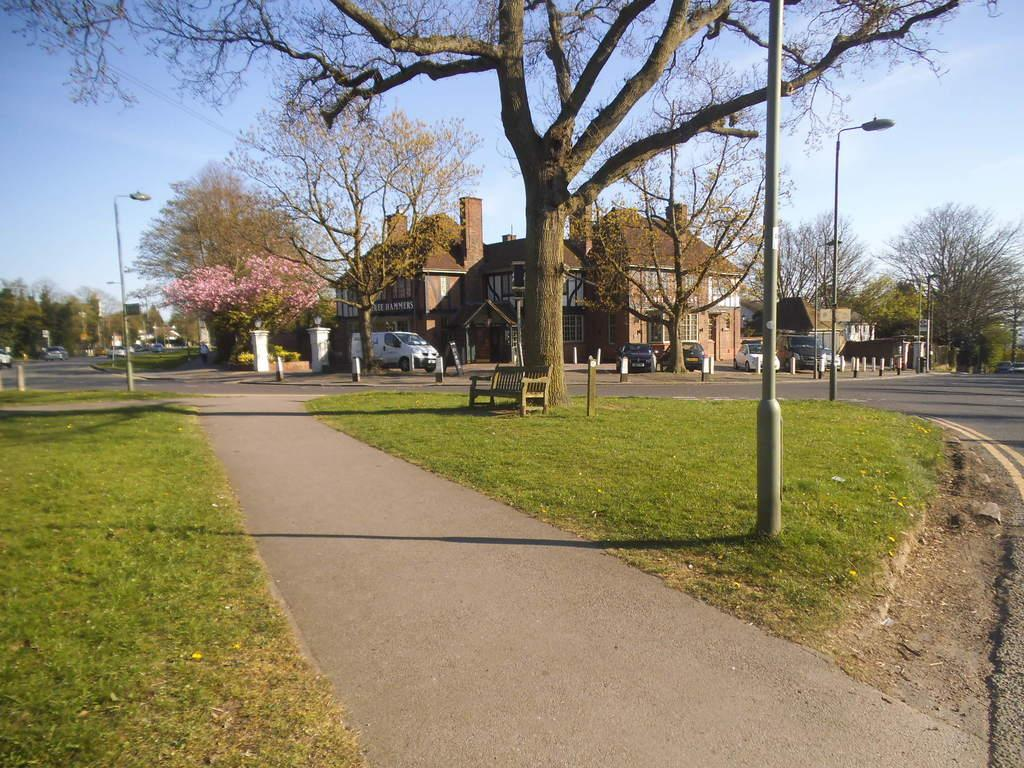What type of vegetation is present in the image? There is grass in the image. What structures are present to provide illumination in the image? There are lights on poles in the image. What type of seating is available in the image? There is a bench in the image. What type of natural feature is present in the image? There is a tree in the image. What type of man-made structure is present in the image? There is a road in the image. What can be seen in the background of the image? In the background, there are buildings, vehicles, trees, and sky. What type of pan is being used to cook on the bench in the image? There is no pan or cooking activity present in the image. What type of base is supporting the tree in the image? The tree is growing naturally in the ground, and there is no separate base supporting it in the image. 